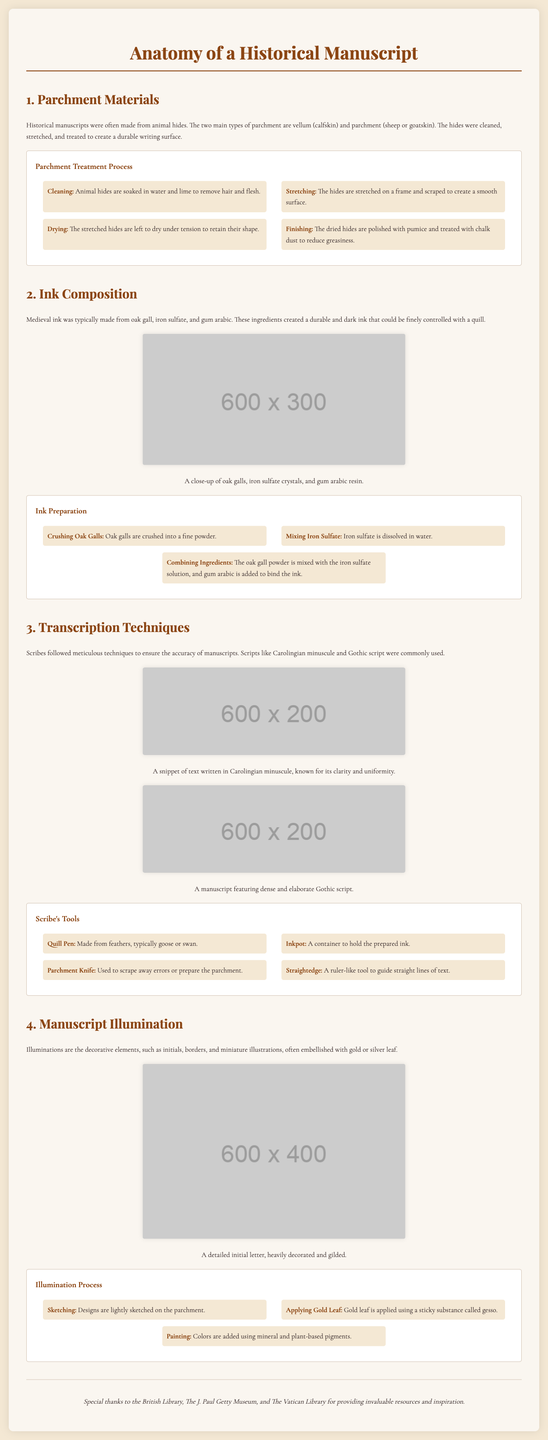What are the two main types of parchment? The document specifies that the two main types of parchment are vellum (calfskin) and parchment (sheep or goatskin).
Answer: vellum and parchment What is a key ingredient in medieval ink? The document mentions that medieval ink was typically made from oak gall, iron sulfate, and gum arabic.
Answer: oak gall What writing style is known for its clarity and uniformity? The document states that Carolingian minuscule is known for its clarity and uniformity.
Answer: Carolingian minuscule How many steps are involved in the parchment treatment process? The parchment treatment process outlined in the document includes four steps: cleaning, stretching, drying, and finishing.
Answer: four What is used to apply gold leaf in the illumination process? The document describes that a sticky substance called gesso is used to apply gold leaf.
Answer: gesso What tool is made from feathers? The document states that the quill pen is made from feathers, typically goose or swan.
Answer: quill pen What type of pigments are used in the illumination process? The document indicates that mineral and plant-based pigments are used in the painting step of the illumination process.
Answer: mineral and plant-based pigments Which component is essential for binding the ink? The document mentions that gum arabic is added to bind the ink.
Answer: gum arabic What decorative elements are present in manuscript illumination? According to the document, the decorative elements in manuscript illumination include initials, borders, and miniature illustrations.
Answer: initials, borders, and miniature illustrations 